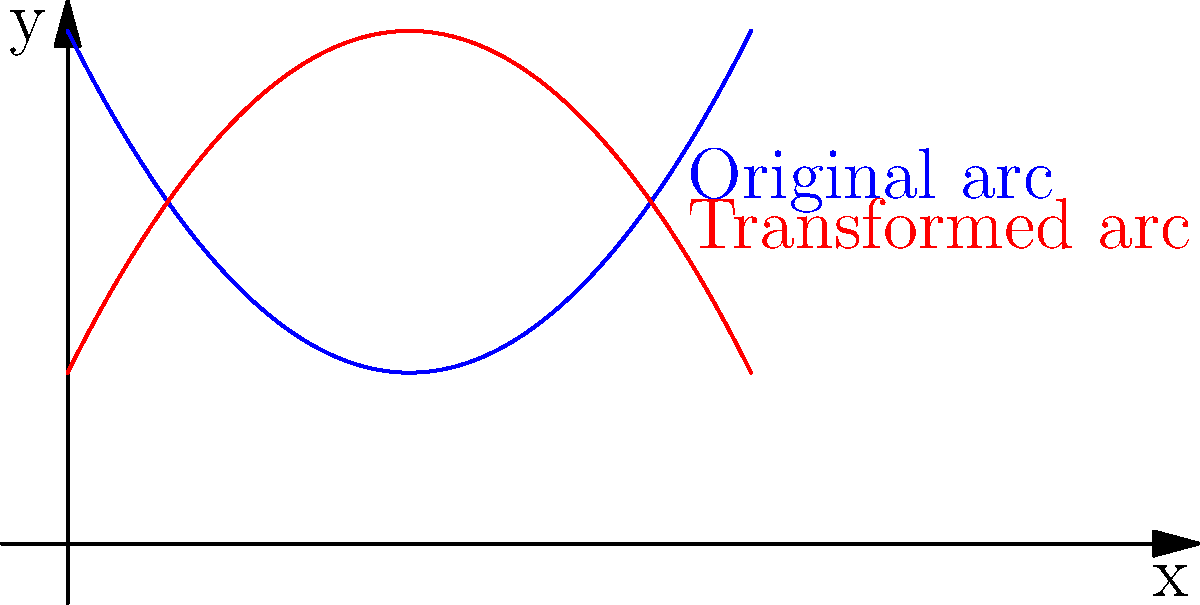In the graph above, the blue curve represents a character's emotional arc throughout a novel. If we wanted to reflect the character's journey to show a contrasting emotional progression, which geometric transformation would be most appropriate to create the red curve? To answer this question, we need to analyze the relationship between the blue and red curves:

1. The blue curve (original arc) is a parabola opening upwards, representing a character's emotional journey that starts high, dips, and then rises again.

2. The red curve (transformed arc) is also a parabola, but it opens downwards, showing an inverted emotional journey.

3. The transformation from the blue curve to the red curve involves two key changes:
   a. The curve is flipped vertically (inverted).
   b. The curve is shifted upwards.

4. In geometric terms, this transformation can be achieved through:
   a. A reflection over the x-axis (y = 0 line)
   b. A vertical translation upwards

5. The reflection over the x-axis inverts the parabola, changing its direction.

6. The vertical translation adjusts the position of the curve to intersect with the original curve at two points.

7. In the context of character development, this transformation represents a complete reversal of the emotional journey, turning positive experiences into negative ones and vice versa.

The most appropriate single transformation to achieve this effect is a reflection over a horizontal line above the x-axis. This combines both the reflection and the translation into one step.
Answer: Reflection over a horizontal line above the x-axis 